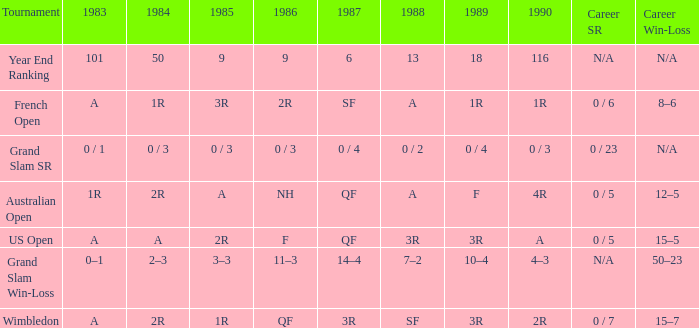What is the result in 1985 when the career win-loss is n/a, and 0 / 23 as the career SR? 0 / 3. 